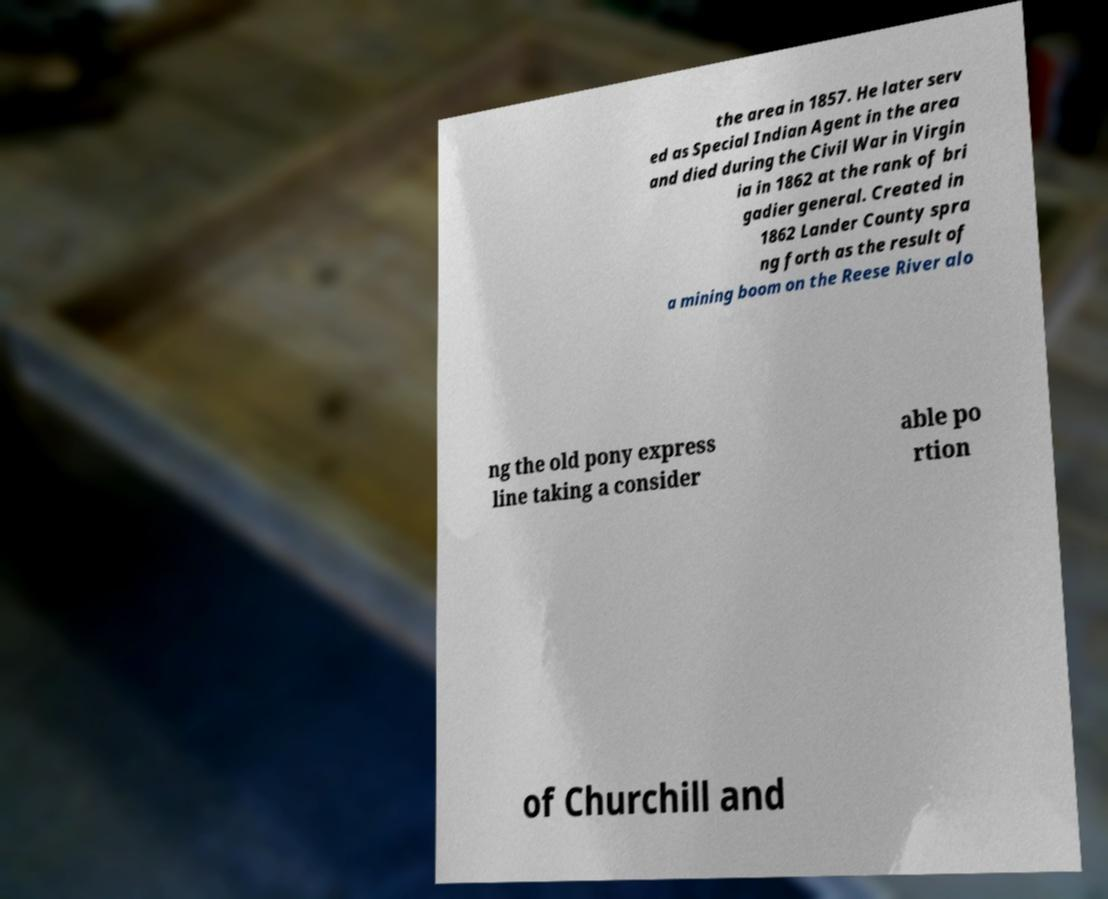I need the written content from this picture converted into text. Can you do that? the area in 1857. He later serv ed as Special Indian Agent in the area and died during the Civil War in Virgin ia in 1862 at the rank of bri gadier general. Created in 1862 Lander County spra ng forth as the result of a mining boom on the Reese River alo ng the old pony express line taking a consider able po rtion of Churchill and 